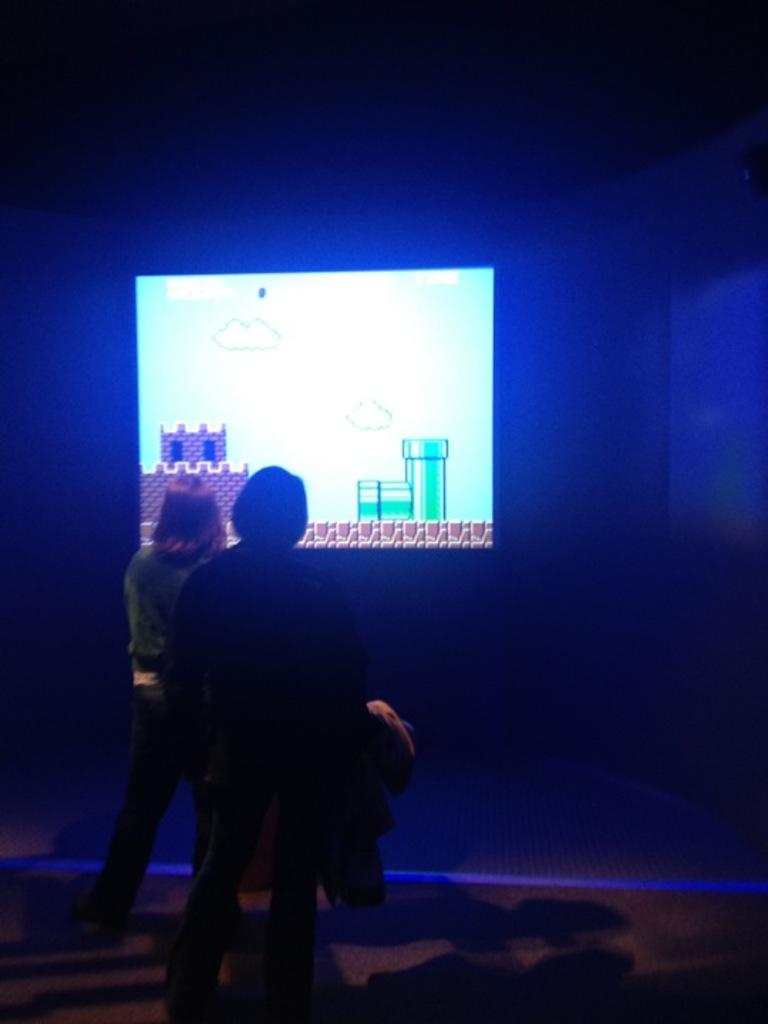How many people are present in the image? There are two people in the image. What are the people doing in the image? The two people are standing on the floor. What is one person holding in the image? One person is holding a cloth. What can be seen on the wall in the background of the image? There is a display screen on a wall in the background. What type of print can be seen on the edge of the scene in the image? There is no print or edge present in the image; it features two people standing on the floor, one holding a cloth, and a display screen on a wall in the background. 